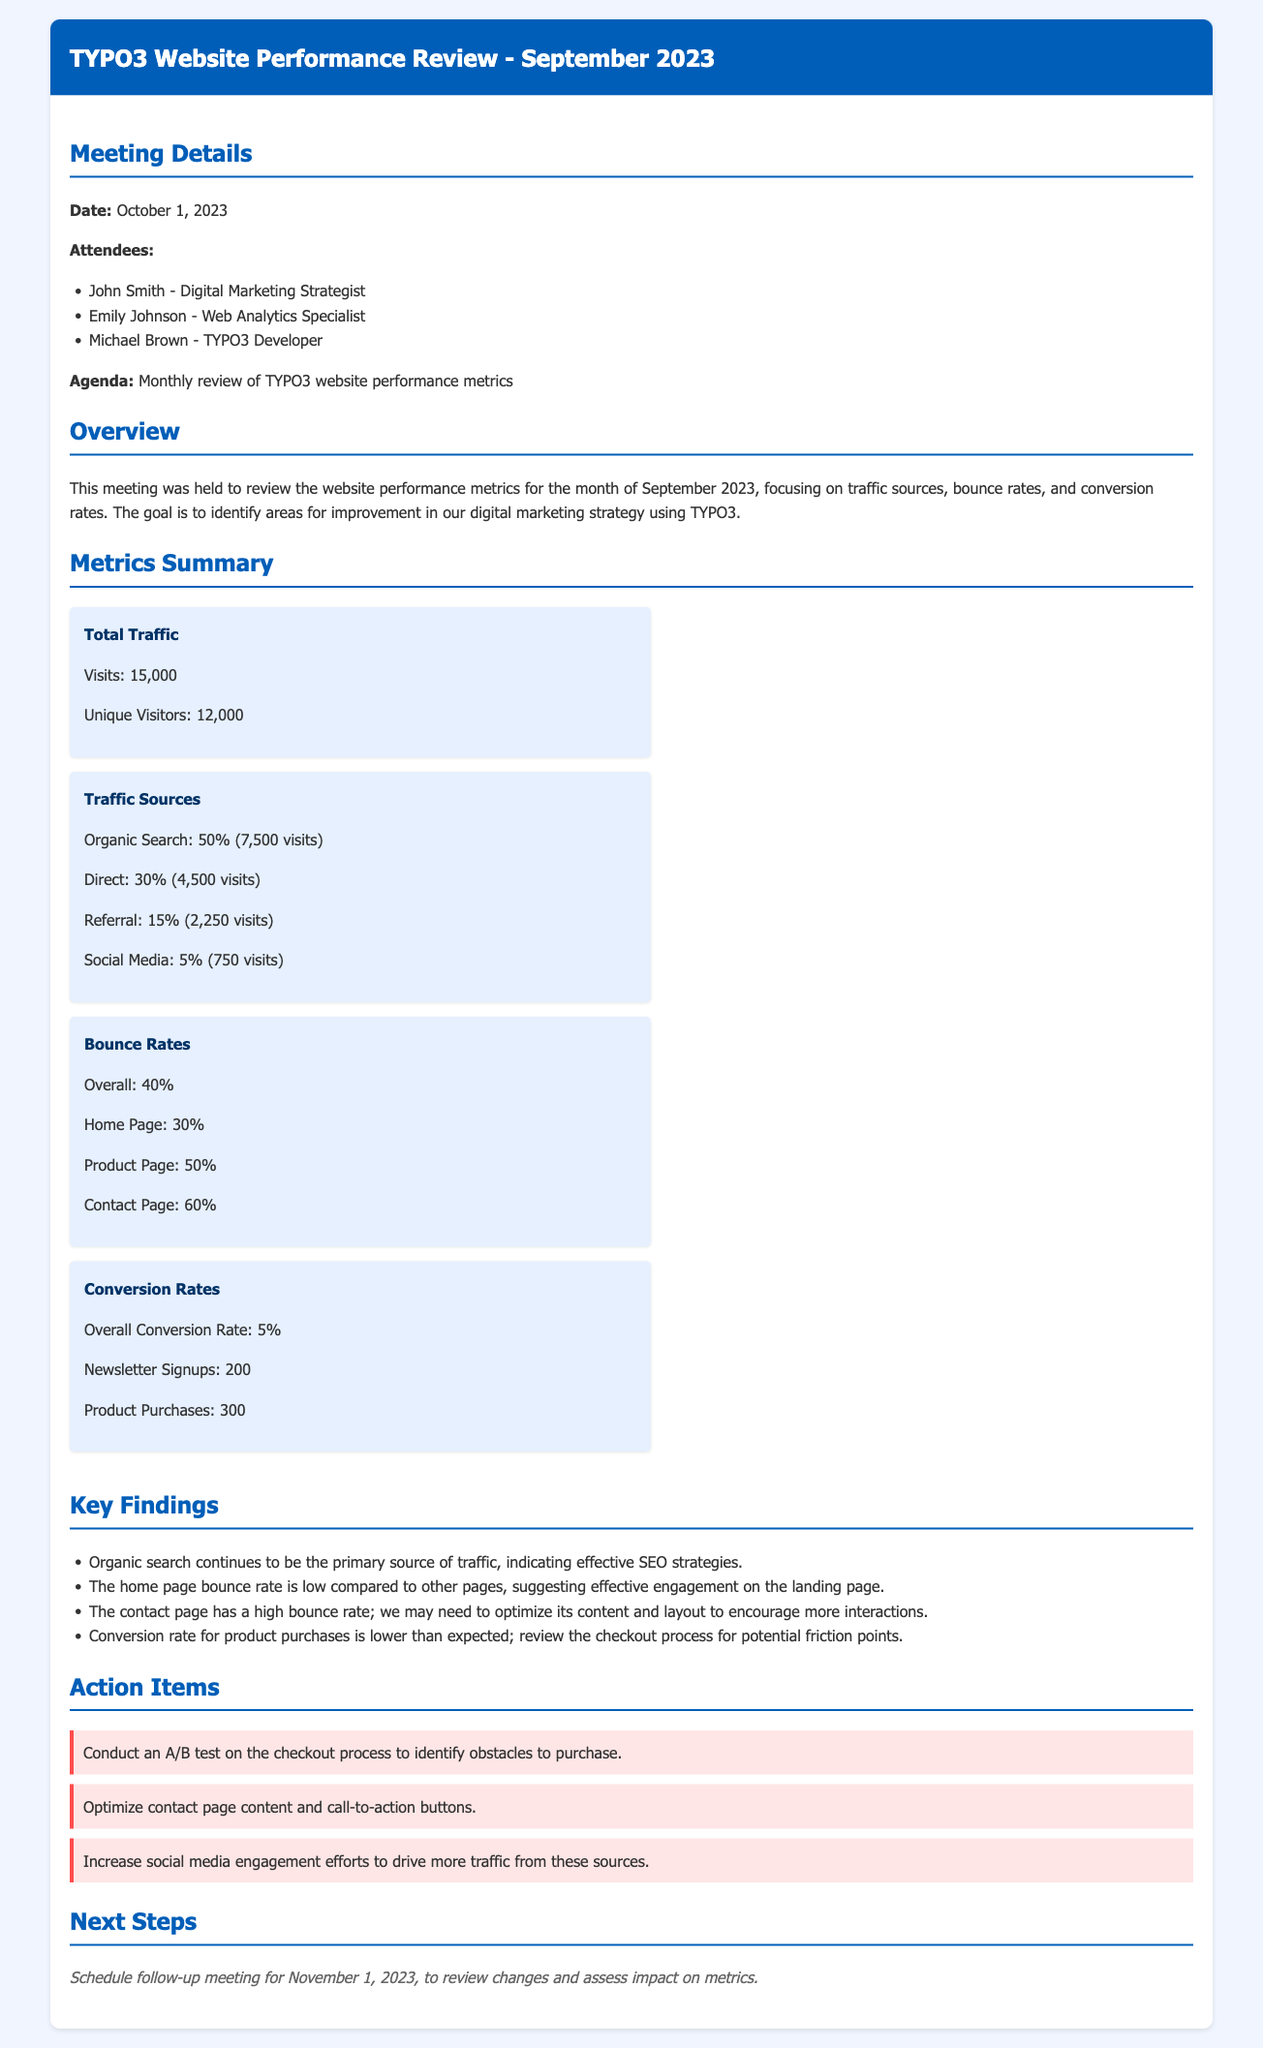What is the total traffic for September 2023? The total traffic is the sum of visits as indicated in the metrics summary, which shows 15,000 visits.
Answer: 15,000 What are the percentages of traffic sources? The traffic sources are broken down into percentages: Organic Search is 50%, Direct is 30%, Referral is 15%, and Social Media is 5%.
Answer: 50%, 30%, 15%, 5% What is the overall conversion rate? The overall conversion rate is specifically stated in the metrics summary as 5%.
Answer: 5% Which page has the highest bounce rate? The bounce rates listed indicate that the Contact Page has the highest bounce rate at 60%.
Answer: 60% Who is the Web Analytics Specialist? The document lists attendees, where Emily Johnson is identified as the Web Analytics Specialist.
Answer: Emily Johnson What action is suggested for the checkout process? The action item mentions conducting an A/B test on the checkout process to identify obstacles to purchase.
Answer: Conduct an A/B test What is the date of the follow-up meeting? The next steps section specifies that the follow-up meeting is scheduled for November 1, 2023.
Answer: November 1, 2023 Which traffic source indicates effective SEO strategies? The summary notes that Organic Search is the primary source of traffic, reflecting effective SEO strategies.
Answer: Organic Search Which metric has the lowest bounce rate? The document states that the Home Page has the lowest bounce rate at 30%.
Answer: 30% 